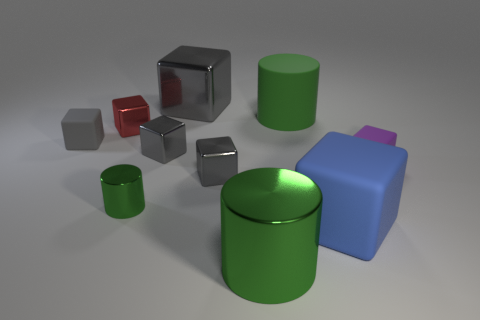Subtract all purple cylinders. How many gray blocks are left? 4 Subtract all purple blocks. How many blocks are left? 6 Subtract all gray metal blocks. How many blocks are left? 4 Subtract all blue blocks. Subtract all cyan spheres. How many blocks are left? 6 Subtract all blocks. How many objects are left? 3 Add 1 shiny things. How many shiny things are left? 7 Add 7 gray matte things. How many gray matte things exist? 8 Subtract 0 blue cylinders. How many objects are left? 10 Subtract all big green metallic objects. Subtract all metal blocks. How many objects are left? 5 